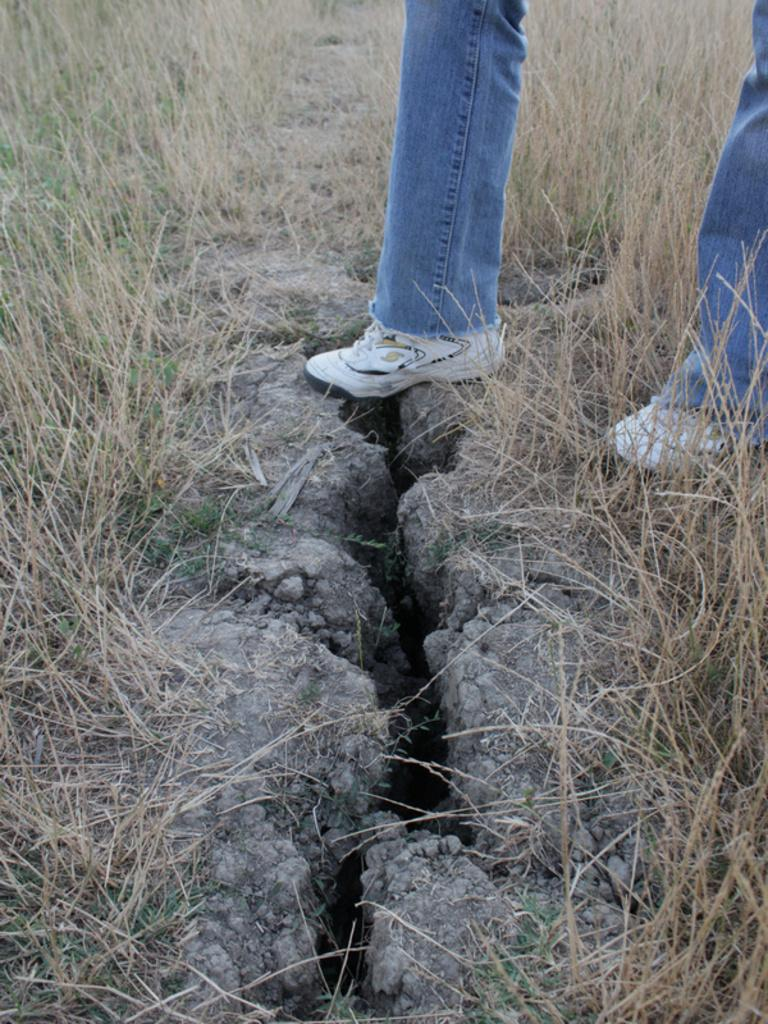What part of a person can be seen in the image? There are legs of a person visible in the image. What type of footwear is the person wearing? The person is wearing shoes. What type of terrain is visible in the image? There is grass in the image. What arithmetic problem is the person solving in the image? There is no indication of any arithmetic problem being solved in the image. What type of brush is the person using to paint the grass in the image? There is no brush or painting activity present in the image. 